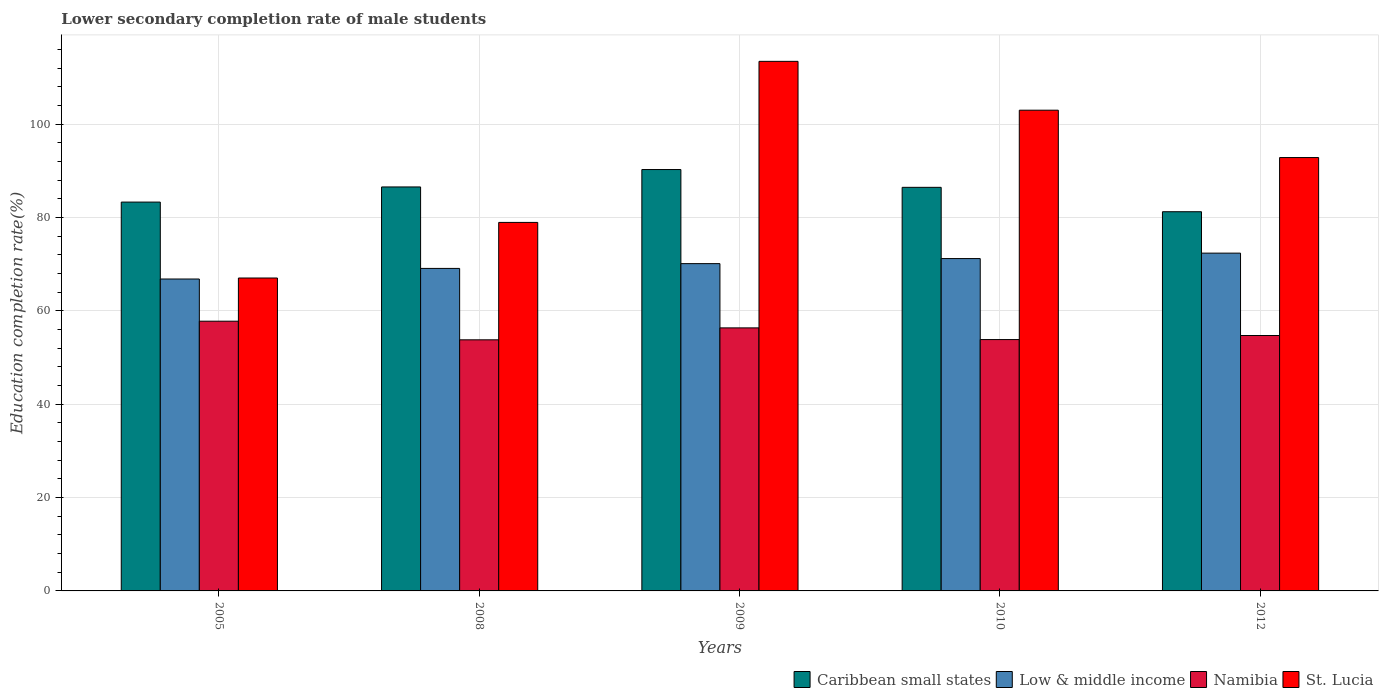How many different coloured bars are there?
Your answer should be compact. 4. Are the number of bars on each tick of the X-axis equal?
Provide a short and direct response. Yes. How many bars are there on the 1st tick from the right?
Your answer should be compact. 4. What is the label of the 5th group of bars from the left?
Offer a terse response. 2012. In how many cases, is the number of bars for a given year not equal to the number of legend labels?
Your answer should be compact. 0. What is the lower secondary completion rate of male students in St. Lucia in 2009?
Provide a short and direct response. 113.47. Across all years, what is the maximum lower secondary completion rate of male students in Caribbean small states?
Offer a terse response. 90.29. Across all years, what is the minimum lower secondary completion rate of male students in Namibia?
Give a very brief answer. 53.8. What is the total lower secondary completion rate of male students in Low & middle income in the graph?
Offer a very short reply. 349.66. What is the difference between the lower secondary completion rate of male students in Caribbean small states in 2008 and that in 2012?
Provide a succinct answer. 5.31. What is the difference between the lower secondary completion rate of male students in St. Lucia in 2005 and the lower secondary completion rate of male students in Caribbean small states in 2012?
Your answer should be compact. -14.2. What is the average lower secondary completion rate of male students in Caribbean small states per year?
Your answer should be very brief. 85.58. In the year 2009, what is the difference between the lower secondary completion rate of male students in Caribbean small states and lower secondary completion rate of male students in Low & middle income?
Provide a succinct answer. 20.16. In how many years, is the lower secondary completion rate of male students in Low & middle income greater than 60 %?
Offer a terse response. 5. What is the ratio of the lower secondary completion rate of male students in Low & middle income in 2005 to that in 2010?
Your response must be concise. 0.94. Is the difference between the lower secondary completion rate of male students in Caribbean small states in 2005 and 2010 greater than the difference between the lower secondary completion rate of male students in Low & middle income in 2005 and 2010?
Give a very brief answer. Yes. What is the difference between the highest and the second highest lower secondary completion rate of male students in Low & middle income?
Keep it short and to the point. 1.16. What is the difference between the highest and the lowest lower secondary completion rate of male students in St. Lucia?
Offer a very short reply. 46.42. In how many years, is the lower secondary completion rate of male students in St. Lucia greater than the average lower secondary completion rate of male students in St. Lucia taken over all years?
Your response must be concise. 3. Is it the case that in every year, the sum of the lower secondary completion rate of male students in Caribbean small states and lower secondary completion rate of male students in St. Lucia is greater than the sum of lower secondary completion rate of male students in Namibia and lower secondary completion rate of male students in Low & middle income?
Your response must be concise. Yes. What does the 2nd bar from the left in 2005 represents?
Your response must be concise. Low & middle income. How many bars are there?
Your response must be concise. 20. Are all the bars in the graph horizontal?
Your answer should be compact. No. How many years are there in the graph?
Your answer should be very brief. 5. Are the values on the major ticks of Y-axis written in scientific E-notation?
Keep it short and to the point. No. Does the graph contain grids?
Your response must be concise. Yes. How are the legend labels stacked?
Offer a very short reply. Horizontal. What is the title of the graph?
Ensure brevity in your answer.  Lower secondary completion rate of male students. Does "Turkmenistan" appear as one of the legend labels in the graph?
Provide a short and direct response. No. What is the label or title of the X-axis?
Your answer should be compact. Years. What is the label or title of the Y-axis?
Offer a very short reply. Education completion rate(%). What is the Education completion rate(%) of Caribbean small states in 2005?
Ensure brevity in your answer.  83.32. What is the Education completion rate(%) in Low & middle income in 2005?
Give a very brief answer. 66.83. What is the Education completion rate(%) of Namibia in 2005?
Provide a short and direct response. 57.8. What is the Education completion rate(%) in St. Lucia in 2005?
Offer a terse response. 67.05. What is the Education completion rate(%) of Caribbean small states in 2008?
Your answer should be very brief. 86.56. What is the Education completion rate(%) of Low & middle income in 2008?
Give a very brief answer. 69.11. What is the Education completion rate(%) in Namibia in 2008?
Make the answer very short. 53.8. What is the Education completion rate(%) of St. Lucia in 2008?
Provide a short and direct response. 78.96. What is the Education completion rate(%) of Caribbean small states in 2009?
Offer a terse response. 90.29. What is the Education completion rate(%) in Low & middle income in 2009?
Ensure brevity in your answer.  70.13. What is the Education completion rate(%) of Namibia in 2009?
Your answer should be very brief. 56.36. What is the Education completion rate(%) in St. Lucia in 2009?
Your answer should be very brief. 113.47. What is the Education completion rate(%) in Caribbean small states in 2010?
Your answer should be compact. 86.48. What is the Education completion rate(%) of Low & middle income in 2010?
Keep it short and to the point. 71.21. What is the Education completion rate(%) in Namibia in 2010?
Your response must be concise. 53.86. What is the Education completion rate(%) of St. Lucia in 2010?
Ensure brevity in your answer.  103.01. What is the Education completion rate(%) of Caribbean small states in 2012?
Make the answer very short. 81.25. What is the Education completion rate(%) in Low & middle income in 2012?
Ensure brevity in your answer.  72.38. What is the Education completion rate(%) of Namibia in 2012?
Your response must be concise. 54.73. What is the Education completion rate(%) in St. Lucia in 2012?
Make the answer very short. 92.86. Across all years, what is the maximum Education completion rate(%) of Caribbean small states?
Offer a terse response. 90.29. Across all years, what is the maximum Education completion rate(%) of Low & middle income?
Your answer should be very brief. 72.38. Across all years, what is the maximum Education completion rate(%) in Namibia?
Offer a terse response. 57.8. Across all years, what is the maximum Education completion rate(%) of St. Lucia?
Keep it short and to the point. 113.47. Across all years, what is the minimum Education completion rate(%) in Caribbean small states?
Your answer should be compact. 81.25. Across all years, what is the minimum Education completion rate(%) of Low & middle income?
Your answer should be very brief. 66.83. Across all years, what is the minimum Education completion rate(%) of Namibia?
Make the answer very short. 53.8. Across all years, what is the minimum Education completion rate(%) of St. Lucia?
Make the answer very short. 67.05. What is the total Education completion rate(%) in Caribbean small states in the graph?
Give a very brief answer. 427.9. What is the total Education completion rate(%) in Low & middle income in the graph?
Your answer should be compact. 349.66. What is the total Education completion rate(%) in Namibia in the graph?
Ensure brevity in your answer.  276.54. What is the total Education completion rate(%) in St. Lucia in the graph?
Keep it short and to the point. 455.34. What is the difference between the Education completion rate(%) in Caribbean small states in 2005 and that in 2008?
Make the answer very short. -3.25. What is the difference between the Education completion rate(%) in Low & middle income in 2005 and that in 2008?
Offer a terse response. -2.27. What is the difference between the Education completion rate(%) in Namibia in 2005 and that in 2008?
Ensure brevity in your answer.  3.99. What is the difference between the Education completion rate(%) of St. Lucia in 2005 and that in 2008?
Keep it short and to the point. -11.91. What is the difference between the Education completion rate(%) in Caribbean small states in 2005 and that in 2009?
Offer a very short reply. -6.98. What is the difference between the Education completion rate(%) in Low & middle income in 2005 and that in 2009?
Your answer should be very brief. -3.3. What is the difference between the Education completion rate(%) of Namibia in 2005 and that in 2009?
Ensure brevity in your answer.  1.43. What is the difference between the Education completion rate(%) in St. Lucia in 2005 and that in 2009?
Provide a short and direct response. -46.42. What is the difference between the Education completion rate(%) in Caribbean small states in 2005 and that in 2010?
Give a very brief answer. -3.16. What is the difference between the Education completion rate(%) of Low & middle income in 2005 and that in 2010?
Give a very brief answer. -4.38. What is the difference between the Education completion rate(%) in Namibia in 2005 and that in 2010?
Give a very brief answer. 3.94. What is the difference between the Education completion rate(%) of St. Lucia in 2005 and that in 2010?
Provide a short and direct response. -35.96. What is the difference between the Education completion rate(%) of Caribbean small states in 2005 and that in 2012?
Your response must be concise. 2.06. What is the difference between the Education completion rate(%) in Low & middle income in 2005 and that in 2012?
Keep it short and to the point. -5.54. What is the difference between the Education completion rate(%) in Namibia in 2005 and that in 2012?
Your response must be concise. 3.07. What is the difference between the Education completion rate(%) in St. Lucia in 2005 and that in 2012?
Ensure brevity in your answer.  -25.81. What is the difference between the Education completion rate(%) of Caribbean small states in 2008 and that in 2009?
Your answer should be compact. -3.73. What is the difference between the Education completion rate(%) of Low & middle income in 2008 and that in 2009?
Ensure brevity in your answer.  -1.02. What is the difference between the Education completion rate(%) in Namibia in 2008 and that in 2009?
Offer a very short reply. -2.56. What is the difference between the Education completion rate(%) of St. Lucia in 2008 and that in 2009?
Your answer should be compact. -34.51. What is the difference between the Education completion rate(%) of Caribbean small states in 2008 and that in 2010?
Provide a short and direct response. 0.08. What is the difference between the Education completion rate(%) of Low & middle income in 2008 and that in 2010?
Your response must be concise. -2.11. What is the difference between the Education completion rate(%) in Namibia in 2008 and that in 2010?
Your response must be concise. -0.05. What is the difference between the Education completion rate(%) in St. Lucia in 2008 and that in 2010?
Offer a very short reply. -24.05. What is the difference between the Education completion rate(%) of Caribbean small states in 2008 and that in 2012?
Give a very brief answer. 5.31. What is the difference between the Education completion rate(%) in Low & middle income in 2008 and that in 2012?
Provide a succinct answer. -3.27. What is the difference between the Education completion rate(%) in Namibia in 2008 and that in 2012?
Provide a short and direct response. -0.92. What is the difference between the Education completion rate(%) in St. Lucia in 2008 and that in 2012?
Your answer should be compact. -13.9. What is the difference between the Education completion rate(%) of Caribbean small states in 2009 and that in 2010?
Your answer should be very brief. 3.81. What is the difference between the Education completion rate(%) of Low & middle income in 2009 and that in 2010?
Your response must be concise. -1.09. What is the difference between the Education completion rate(%) of Namibia in 2009 and that in 2010?
Make the answer very short. 2.5. What is the difference between the Education completion rate(%) of St. Lucia in 2009 and that in 2010?
Provide a succinct answer. 10.47. What is the difference between the Education completion rate(%) of Caribbean small states in 2009 and that in 2012?
Your answer should be very brief. 9.04. What is the difference between the Education completion rate(%) of Low & middle income in 2009 and that in 2012?
Make the answer very short. -2.25. What is the difference between the Education completion rate(%) in Namibia in 2009 and that in 2012?
Ensure brevity in your answer.  1.64. What is the difference between the Education completion rate(%) in St. Lucia in 2009 and that in 2012?
Give a very brief answer. 20.61. What is the difference between the Education completion rate(%) of Caribbean small states in 2010 and that in 2012?
Ensure brevity in your answer.  5.22. What is the difference between the Education completion rate(%) in Low & middle income in 2010 and that in 2012?
Make the answer very short. -1.16. What is the difference between the Education completion rate(%) of Namibia in 2010 and that in 2012?
Your answer should be very brief. -0.87. What is the difference between the Education completion rate(%) in St. Lucia in 2010 and that in 2012?
Offer a terse response. 10.15. What is the difference between the Education completion rate(%) of Caribbean small states in 2005 and the Education completion rate(%) of Low & middle income in 2008?
Offer a terse response. 14.21. What is the difference between the Education completion rate(%) of Caribbean small states in 2005 and the Education completion rate(%) of Namibia in 2008?
Give a very brief answer. 29.51. What is the difference between the Education completion rate(%) in Caribbean small states in 2005 and the Education completion rate(%) in St. Lucia in 2008?
Provide a short and direct response. 4.36. What is the difference between the Education completion rate(%) of Low & middle income in 2005 and the Education completion rate(%) of Namibia in 2008?
Provide a short and direct response. 13.03. What is the difference between the Education completion rate(%) in Low & middle income in 2005 and the Education completion rate(%) in St. Lucia in 2008?
Provide a succinct answer. -12.13. What is the difference between the Education completion rate(%) in Namibia in 2005 and the Education completion rate(%) in St. Lucia in 2008?
Your response must be concise. -21.16. What is the difference between the Education completion rate(%) in Caribbean small states in 2005 and the Education completion rate(%) in Low & middle income in 2009?
Your answer should be very brief. 13.19. What is the difference between the Education completion rate(%) of Caribbean small states in 2005 and the Education completion rate(%) of Namibia in 2009?
Provide a short and direct response. 26.95. What is the difference between the Education completion rate(%) in Caribbean small states in 2005 and the Education completion rate(%) in St. Lucia in 2009?
Your response must be concise. -30.16. What is the difference between the Education completion rate(%) in Low & middle income in 2005 and the Education completion rate(%) in Namibia in 2009?
Provide a short and direct response. 10.47. What is the difference between the Education completion rate(%) of Low & middle income in 2005 and the Education completion rate(%) of St. Lucia in 2009?
Your answer should be very brief. -46.64. What is the difference between the Education completion rate(%) in Namibia in 2005 and the Education completion rate(%) in St. Lucia in 2009?
Your answer should be compact. -55.68. What is the difference between the Education completion rate(%) in Caribbean small states in 2005 and the Education completion rate(%) in Low & middle income in 2010?
Make the answer very short. 12.1. What is the difference between the Education completion rate(%) in Caribbean small states in 2005 and the Education completion rate(%) in Namibia in 2010?
Keep it short and to the point. 29.46. What is the difference between the Education completion rate(%) in Caribbean small states in 2005 and the Education completion rate(%) in St. Lucia in 2010?
Your answer should be very brief. -19.69. What is the difference between the Education completion rate(%) of Low & middle income in 2005 and the Education completion rate(%) of Namibia in 2010?
Offer a very short reply. 12.98. What is the difference between the Education completion rate(%) of Low & middle income in 2005 and the Education completion rate(%) of St. Lucia in 2010?
Make the answer very short. -36.17. What is the difference between the Education completion rate(%) of Namibia in 2005 and the Education completion rate(%) of St. Lucia in 2010?
Your answer should be very brief. -45.21. What is the difference between the Education completion rate(%) of Caribbean small states in 2005 and the Education completion rate(%) of Low & middle income in 2012?
Provide a succinct answer. 10.94. What is the difference between the Education completion rate(%) of Caribbean small states in 2005 and the Education completion rate(%) of Namibia in 2012?
Provide a short and direct response. 28.59. What is the difference between the Education completion rate(%) of Caribbean small states in 2005 and the Education completion rate(%) of St. Lucia in 2012?
Give a very brief answer. -9.54. What is the difference between the Education completion rate(%) in Low & middle income in 2005 and the Education completion rate(%) in Namibia in 2012?
Offer a terse response. 12.11. What is the difference between the Education completion rate(%) of Low & middle income in 2005 and the Education completion rate(%) of St. Lucia in 2012?
Provide a short and direct response. -26.02. What is the difference between the Education completion rate(%) in Namibia in 2005 and the Education completion rate(%) in St. Lucia in 2012?
Ensure brevity in your answer.  -35.06. What is the difference between the Education completion rate(%) of Caribbean small states in 2008 and the Education completion rate(%) of Low & middle income in 2009?
Make the answer very short. 16.43. What is the difference between the Education completion rate(%) in Caribbean small states in 2008 and the Education completion rate(%) in Namibia in 2009?
Give a very brief answer. 30.2. What is the difference between the Education completion rate(%) of Caribbean small states in 2008 and the Education completion rate(%) of St. Lucia in 2009?
Ensure brevity in your answer.  -26.91. What is the difference between the Education completion rate(%) in Low & middle income in 2008 and the Education completion rate(%) in Namibia in 2009?
Make the answer very short. 12.74. What is the difference between the Education completion rate(%) of Low & middle income in 2008 and the Education completion rate(%) of St. Lucia in 2009?
Your answer should be very brief. -44.37. What is the difference between the Education completion rate(%) of Namibia in 2008 and the Education completion rate(%) of St. Lucia in 2009?
Keep it short and to the point. -59.67. What is the difference between the Education completion rate(%) in Caribbean small states in 2008 and the Education completion rate(%) in Low & middle income in 2010?
Make the answer very short. 15.35. What is the difference between the Education completion rate(%) in Caribbean small states in 2008 and the Education completion rate(%) in Namibia in 2010?
Your answer should be very brief. 32.7. What is the difference between the Education completion rate(%) in Caribbean small states in 2008 and the Education completion rate(%) in St. Lucia in 2010?
Offer a terse response. -16.44. What is the difference between the Education completion rate(%) of Low & middle income in 2008 and the Education completion rate(%) of Namibia in 2010?
Provide a short and direct response. 15.25. What is the difference between the Education completion rate(%) in Low & middle income in 2008 and the Education completion rate(%) in St. Lucia in 2010?
Provide a short and direct response. -33.9. What is the difference between the Education completion rate(%) of Namibia in 2008 and the Education completion rate(%) of St. Lucia in 2010?
Your answer should be very brief. -49.2. What is the difference between the Education completion rate(%) in Caribbean small states in 2008 and the Education completion rate(%) in Low & middle income in 2012?
Make the answer very short. 14.18. What is the difference between the Education completion rate(%) of Caribbean small states in 2008 and the Education completion rate(%) of Namibia in 2012?
Your response must be concise. 31.83. What is the difference between the Education completion rate(%) of Caribbean small states in 2008 and the Education completion rate(%) of St. Lucia in 2012?
Offer a very short reply. -6.3. What is the difference between the Education completion rate(%) of Low & middle income in 2008 and the Education completion rate(%) of Namibia in 2012?
Keep it short and to the point. 14.38. What is the difference between the Education completion rate(%) in Low & middle income in 2008 and the Education completion rate(%) in St. Lucia in 2012?
Your answer should be compact. -23.75. What is the difference between the Education completion rate(%) in Namibia in 2008 and the Education completion rate(%) in St. Lucia in 2012?
Offer a terse response. -39.05. What is the difference between the Education completion rate(%) in Caribbean small states in 2009 and the Education completion rate(%) in Low & middle income in 2010?
Make the answer very short. 19.08. What is the difference between the Education completion rate(%) of Caribbean small states in 2009 and the Education completion rate(%) of Namibia in 2010?
Your answer should be very brief. 36.43. What is the difference between the Education completion rate(%) in Caribbean small states in 2009 and the Education completion rate(%) in St. Lucia in 2010?
Your answer should be very brief. -12.71. What is the difference between the Education completion rate(%) of Low & middle income in 2009 and the Education completion rate(%) of Namibia in 2010?
Offer a terse response. 16.27. What is the difference between the Education completion rate(%) of Low & middle income in 2009 and the Education completion rate(%) of St. Lucia in 2010?
Give a very brief answer. -32.88. What is the difference between the Education completion rate(%) in Namibia in 2009 and the Education completion rate(%) in St. Lucia in 2010?
Your response must be concise. -46.64. What is the difference between the Education completion rate(%) in Caribbean small states in 2009 and the Education completion rate(%) in Low & middle income in 2012?
Your answer should be compact. 17.91. What is the difference between the Education completion rate(%) of Caribbean small states in 2009 and the Education completion rate(%) of Namibia in 2012?
Your response must be concise. 35.57. What is the difference between the Education completion rate(%) of Caribbean small states in 2009 and the Education completion rate(%) of St. Lucia in 2012?
Your response must be concise. -2.57. What is the difference between the Education completion rate(%) in Low & middle income in 2009 and the Education completion rate(%) in Namibia in 2012?
Your answer should be very brief. 15.4. What is the difference between the Education completion rate(%) of Low & middle income in 2009 and the Education completion rate(%) of St. Lucia in 2012?
Your response must be concise. -22.73. What is the difference between the Education completion rate(%) in Namibia in 2009 and the Education completion rate(%) in St. Lucia in 2012?
Ensure brevity in your answer.  -36.5. What is the difference between the Education completion rate(%) in Caribbean small states in 2010 and the Education completion rate(%) in Low & middle income in 2012?
Your answer should be very brief. 14.1. What is the difference between the Education completion rate(%) in Caribbean small states in 2010 and the Education completion rate(%) in Namibia in 2012?
Make the answer very short. 31.75. What is the difference between the Education completion rate(%) in Caribbean small states in 2010 and the Education completion rate(%) in St. Lucia in 2012?
Your response must be concise. -6.38. What is the difference between the Education completion rate(%) of Low & middle income in 2010 and the Education completion rate(%) of Namibia in 2012?
Ensure brevity in your answer.  16.49. What is the difference between the Education completion rate(%) of Low & middle income in 2010 and the Education completion rate(%) of St. Lucia in 2012?
Offer a very short reply. -21.64. What is the difference between the Education completion rate(%) in Namibia in 2010 and the Education completion rate(%) in St. Lucia in 2012?
Give a very brief answer. -39. What is the average Education completion rate(%) in Caribbean small states per year?
Provide a succinct answer. 85.58. What is the average Education completion rate(%) of Low & middle income per year?
Keep it short and to the point. 69.93. What is the average Education completion rate(%) of Namibia per year?
Your response must be concise. 55.31. What is the average Education completion rate(%) of St. Lucia per year?
Your answer should be compact. 91.07. In the year 2005, what is the difference between the Education completion rate(%) of Caribbean small states and Education completion rate(%) of Low & middle income?
Your answer should be compact. 16.48. In the year 2005, what is the difference between the Education completion rate(%) of Caribbean small states and Education completion rate(%) of Namibia?
Offer a terse response. 25.52. In the year 2005, what is the difference between the Education completion rate(%) in Caribbean small states and Education completion rate(%) in St. Lucia?
Offer a very short reply. 16.27. In the year 2005, what is the difference between the Education completion rate(%) of Low & middle income and Education completion rate(%) of Namibia?
Keep it short and to the point. 9.04. In the year 2005, what is the difference between the Education completion rate(%) in Low & middle income and Education completion rate(%) in St. Lucia?
Your response must be concise. -0.22. In the year 2005, what is the difference between the Education completion rate(%) in Namibia and Education completion rate(%) in St. Lucia?
Offer a terse response. -9.25. In the year 2008, what is the difference between the Education completion rate(%) in Caribbean small states and Education completion rate(%) in Low & middle income?
Provide a succinct answer. 17.46. In the year 2008, what is the difference between the Education completion rate(%) in Caribbean small states and Education completion rate(%) in Namibia?
Your response must be concise. 32.76. In the year 2008, what is the difference between the Education completion rate(%) of Caribbean small states and Education completion rate(%) of St. Lucia?
Offer a terse response. 7.6. In the year 2008, what is the difference between the Education completion rate(%) of Low & middle income and Education completion rate(%) of Namibia?
Provide a succinct answer. 15.3. In the year 2008, what is the difference between the Education completion rate(%) in Low & middle income and Education completion rate(%) in St. Lucia?
Provide a short and direct response. -9.85. In the year 2008, what is the difference between the Education completion rate(%) of Namibia and Education completion rate(%) of St. Lucia?
Keep it short and to the point. -25.16. In the year 2009, what is the difference between the Education completion rate(%) of Caribbean small states and Education completion rate(%) of Low & middle income?
Provide a succinct answer. 20.16. In the year 2009, what is the difference between the Education completion rate(%) in Caribbean small states and Education completion rate(%) in Namibia?
Make the answer very short. 33.93. In the year 2009, what is the difference between the Education completion rate(%) of Caribbean small states and Education completion rate(%) of St. Lucia?
Your answer should be very brief. -23.18. In the year 2009, what is the difference between the Education completion rate(%) in Low & middle income and Education completion rate(%) in Namibia?
Your answer should be very brief. 13.77. In the year 2009, what is the difference between the Education completion rate(%) of Low & middle income and Education completion rate(%) of St. Lucia?
Provide a succinct answer. -43.34. In the year 2009, what is the difference between the Education completion rate(%) of Namibia and Education completion rate(%) of St. Lucia?
Keep it short and to the point. -57.11. In the year 2010, what is the difference between the Education completion rate(%) in Caribbean small states and Education completion rate(%) in Low & middle income?
Provide a short and direct response. 15.26. In the year 2010, what is the difference between the Education completion rate(%) in Caribbean small states and Education completion rate(%) in Namibia?
Give a very brief answer. 32.62. In the year 2010, what is the difference between the Education completion rate(%) of Caribbean small states and Education completion rate(%) of St. Lucia?
Keep it short and to the point. -16.53. In the year 2010, what is the difference between the Education completion rate(%) of Low & middle income and Education completion rate(%) of Namibia?
Offer a very short reply. 17.36. In the year 2010, what is the difference between the Education completion rate(%) in Low & middle income and Education completion rate(%) in St. Lucia?
Your response must be concise. -31.79. In the year 2010, what is the difference between the Education completion rate(%) of Namibia and Education completion rate(%) of St. Lucia?
Provide a succinct answer. -49.15. In the year 2012, what is the difference between the Education completion rate(%) in Caribbean small states and Education completion rate(%) in Low & middle income?
Provide a succinct answer. 8.87. In the year 2012, what is the difference between the Education completion rate(%) of Caribbean small states and Education completion rate(%) of Namibia?
Make the answer very short. 26.53. In the year 2012, what is the difference between the Education completion rate(%) of Caribbean small states and Education completion rate(%) of St. Lucia?
Give a very brief answer. -11.61. In the year 2012, what is the difference between the Education completion rate(%) in Low & middle income and Education completion rate(%) in Namibia?
Your answer should be very brief. 17.65. In the year 2012, what is the difference between the Education completion rate(%) in Low & middle income and Education completion rate(%) in St. Lucia?
Provide a short and direct response. -20.48. In the year 2012, what is the difference between the Education completion rate(%) of Namibia and Education completion rate(%) of St. Lucia?
Provide a short and direct response. -38.13. What is the ratio of the Education completion rate(%) in Caribbean small states in 2005 to that in 2008?
Provide a succinct answer. 0.96. What is the ratio of the Education completion rate(%) of Low & middle income in 2005 to that in 2008?
Make the answer very short. 0.97. What is the ratio of the Education completion rate(%) in Namibia in 2005 to that in 2008?
Your response must be concise. 1.07. What is the ratio of the Education completion rate(%) of St. Lucia in 2005 to that in 2008?
Provide a short and direct response. 0.85. What is the ratio of the Education completion rate(%) of Caribbean small states in 2005 to that in 2009?
Offer a terse response. 0.92. What is the ratio of the Education completion rate(%) in Low & middle income in 2005 to that in 2009?
Your response must be concise. 0.95. What is the ratio of the Education completion rate(%) of Namibia in 2005 to that in 2009?
Ensure brevity in your answer.  1.03. What is the ratio of the Education completion rate(%) of St. Lucia in 2005 to that in 2009?
Your answer should be compact. 0.59. What is the ratio of the Education completion rate(%) in Caribbean small states in 2005 to that in 2010?
Ensure brevity in your answer.  0.96. What is the ratio of the Education completion rate(%) of Low & middle income in 2005 to that in 2010?
Offer a very short reply. 0.94. What is the ratio of the Education completion rate(%) in Namibia in 2005 to that in 2010?
Provide a short and direct response. 1.07. What is the ratio of the Education completion rate(%) of St. Lucia in 2005 to that in 2010?
Your answer should be very brief. 0.65. What is the ratio of the Education completion rate(%) of Caribbean small states in 2005 to that in 2012?
Your answer should be compact. 1.03. What is the ratio of the Education completion rate(%) in Low & middle income in 2005 to that in 2012?
Give a very brief answer. 0.92. What is the ratio of the Education completion rate(%) in Namibia in 2005 to that in 2012?
Give a very brief answer. 1.06. What is the ratio of the Education completion rate(%) of St. Lucia in 2005 to that in 2012?
Offer a very short reply. 0.72. What is the ratio of the Education completion rate(%) in Caribbean small states in 2008 to that in 2009?
Keep it short and to the point. 0.96. What is the ratio of the Education completion rate(%) in Low & middle income in 2008 to that in 2009?
Your answer should be very brief. 0.99. What is the ratio of the Education completion rate(%) of Namibia in 2008 to that in 2009?
Your answer should be very brief. 0.95. What is the ratio of the Education completion rate(%) in St. Lucia in 2008 to that in 2009?
Give a very brief answer. 0.7. What is the ratio of the Education completion rate(%) in Low & middle income in 2008 to that in 2010?
Make the answer very short. 0.97. What is the ratio of the Education completion rate(%) in Namibia in 2008 to that in 2010?
Offer a very short reply. 1. What is the ratio of the Education completion rate(%) of St. Lucia in 2008 to that in 2010?
Provide a succinct answer. 0.77. What is the ratio of the Education completion rate(%) of Caribbean small states in 2008 to that in 2012?
Provide a short and direct response. 1.07. What is the ratio of the Education completion rate(%) in Low & middle income in 2008 to that in 2012?
Give a very brief answer. 0.95. What is the ratio of the Education completion rate(%) of Namibia in 2008 to that in 2012?
Provide a short and direct response. 0.98. What is the ratio of the Education completion rate(%) of St. Lucia in 2008 to that in 2012?
Your response must be concise. 0.85. What is the ratio of the Education completion rate(%) of Caribbean small states in 2009 to that in 2010?
Offer a terse response. 1.04. What is the ratio of the Education completion rate(%) of Namibia in 2009 to that in 2010?
Ensure brevity in your answer.  1.05. What is the ratio of the Education completion rate(%) of St. Lucia in 2009 to that in 2010?
Your response must be concise. 1.1. What is the ratio of the Education completion rate(%) of Caribbean small states in 2009 to that in 2012?
Offer a terse response. 1.11. What is the ratio of the Education completion rate(%) in Low & middle income in 2009 to that in 2012?
Make the answer very short. 0.97. What is the ratio of the Education completion rate(%) of Namibia in 2009 to that in 2012?
Ensure brevity in your answer.  1.03. What is the ratio of the Education completion rate(%) of St. Lucia in 2009 to that in 2012?
Your response must be concise. 1.22. What is the ratio of the Education completion rate(%) in Caribbean small states in 2010 to that in 2012?
Your response must be concise. 1.06. What is the ratio of the Education completion rate(%) of Low & middle income in 2010 to that in 2012?
Make the answer very short. 0.98. What is the ratio of the Education completion rate(%) of Namibia in 2010 to that in 2012?
Give a very brief answer. 0.98. What is the ratio of the Education completion rate(%) of St. Lucia in 2010 to that in 2012?
Your response must be concise. 1.11. What is the difference between the highest and the second highest Education completion rate(%) of Caribbean small states?
Keep it short and to the point. 3.73. What is the difference between the highest and the second highest Education completion rate(%) in Low & middle income?
Your answer should be compact. 1.16. What is the difference between the highest and the second highest Education completion rate(%) of Namibia?
Keep it short and to the point. 1.43. What is the difference between the highest and the second highest Education completion rate(%) of St. Lucia?
Your response must be concise. 10.47. What is the difference between the highest and the lowest Education completion rate(%) in Caribbean small states?
Offer a very short reply. 9.04. What is the difference between the highest and the lowest Education completion rate(%) in Low & middle income?
Ensure brevity in your answer.  5.54. What is the difference between the highest and the lowest Education completion rate(%) of Namibia?
Your answer should be compact. 3.99. What is the difference between the highest and the lowest Education completion rate(%) in St. Lucia?
Ensure brevity in your answer.  46.42. 